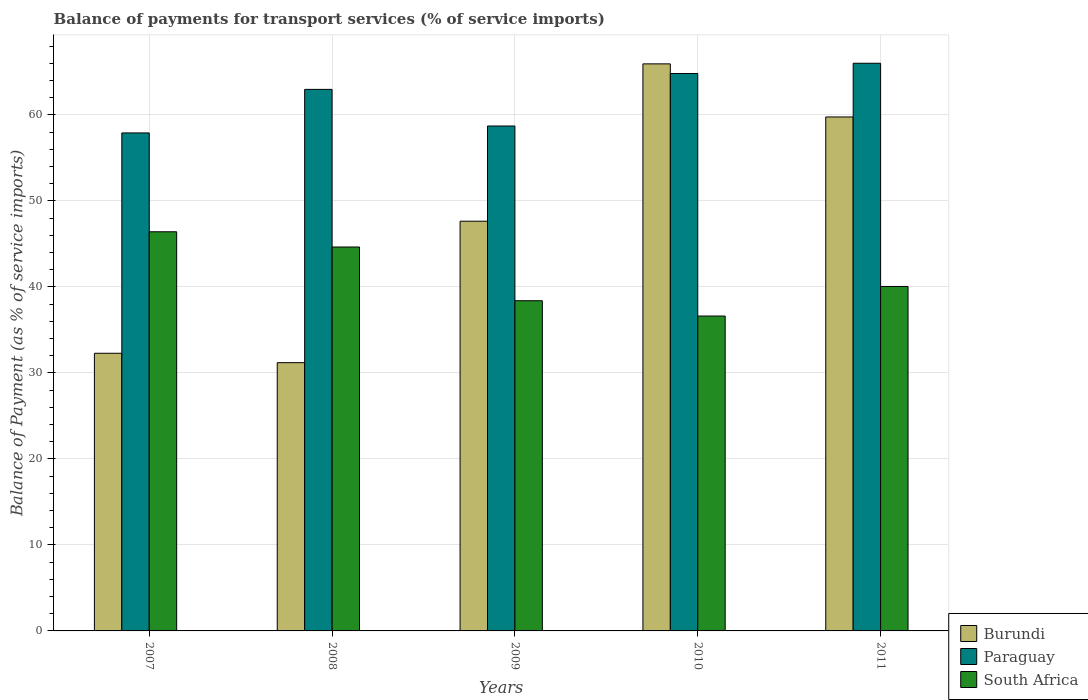How many different coloured bars are there?
Your answer should be very brief. 3. Are the number of bars on each tick of the X-axis equal?
Your answer should be compact. Yes. How many bars are there on the 4th tick from the right?
Make the answer very short. 3. What is the balance of payments for transport services in Paraguay in 2009?
Your response must be concise. 58.71. Across all years, what is the maximum balance of payments for transport services in Burundi?
Offer a very short reply. 65.93. Across all years, what is the minimum balance of payments for transport services in South Africa?
Your answer should be compact. 36.61. In which year was the balance of payments for transport services in South Africa maximum?
Your response must be concise. 2007. In which year was the balance of payments for transport services in South Africa minimum?
Give a very brief answer. 2010. What is the total balance of payments for transport services in Paraguay in the graph?
Your response must be concise. 310.39. What is the difference between the balance of payments for transport services in South Africa in 2007 and that in 2008?
Provide a short and direct response. 1.77. What is the difference between the balance of payments for transport services in South Africa in 2007 and the balance of payments for transport services in Burundi in 2010?
Provide a succinct answer. -19.52. What is the average balance of payments for transport services in Paraguay per year?
Make the answer very short. 62.08. In the year 2007, what is the difference between the balance of payments for transport services in Burundi and balance of payments for transport services in South Africa?
Your answer should be very brief. -14.13. What is the ratio of the balance of payments for transport services in Burundi in 2007 to that in 2009?
Provide a succinct answer. 0.68. Is the difference between the balance of payments for transport services in Burundi in 2007 and 2009 greater than the difference between the balance of payments for transport services in South Africa in 2007 and 2009?
Your answer should be compact. No. What is the difference between the highest and the second highest balance of payments for transport services in Paraguay?
Ensure brevity in your answer.  1.19. What is the difference between the highest and the lowest balance of payments for transport services in South Africa?
Ensure brevity in your answer.  9.8. In how many years, is the balance of payments for transport services in South Africa greater than the average balance of payments for transport services in South Africa taken over all years?
Offer a very short reply. 2. What does the 1st bar from the left in 2008 represents?
Give a very brief answer. Burundi. What does the 3rd bar from the right in 2010 represents?
Offer a very short reply. Burundi. Is it the case that in every year, the sum of the balance of payments for transport services in Burundi and balance of payments for transport services in South Africa is greater than the balance of payments for transport services in Paraguay?
Your answer should be compact. Yes. How many bars are there?
Ensure brevity in your answer.  15. Are the values on the major ticks of Y-axis written in scientific E-notation?
Ensure brevity in your answer.  No. Does the graph contain any zero values?
Your response must be concise. No. Where does the legend appear in the graph?
Offer a terse response. Bottom right. How many legend labels are there?
Provide a short and direct response. 3. What is the title of the graph?
Offer a terse response. Balance of payments for transport services (% of service imports). Does "South Asia" appear as one of the legend labels in the graph?
Make the answer very short. No. What is the label or title of the X-axis?
Provide a succinct answer. Years. What is the label or title of the Y-axis?
Offer a very short reply. Balance of Payment (as % of service imports). What is the Balance of Payment (as % of service imports) in Burundi in 2007?
Ensure brevity in your answer.  32.28. What is the Balance of Payment (as % of service imports) in Paraguay in 2007?
Your answer should be compact. 57.9. What is the Balance of Payment (as % of service imports) in South Africa in 2007?
Your answer should be very brief. 46.41. What is the Balance of Payment (as % of service imports) of Burundi in 2008?
Offer a very short reply. 31.19. What is the Balance of Payment (as % of service imports) in Paraguay in 2008?
Ensure brevity in your answer.  62.97. What is the Balance of Payment (as % of service imports) in South Africa in 2008?
Provide a succinct answer. 44.64. What is the Balance of Payment (as % of service imports) in Burundi in 2009?
Offer a terse response. 47.64. What is the Balance of Payment (as % of service imports) of Paraguay in 2009?
Provide a short and direct response. 58.71. What is the Balance of Payment (as % of service imports) of South Africa in 2009?
Provide a succinct answer. 38.39. What is the Balance of Payment (as % of service imports) of Burundi in 2010?
Keep it short and to the point. 65.93. What is the Balance of Payment (as % of service imports) of Paraguay in 2010?
Your answer should be compact. 64.81. What is the Balance of Payment (as % of service imports) in South Africa in 2010?
Provide a succinct answer. 36.61. What is the Balance of Payment (as % of service imports) of Burundi in 2011?
Provide a short and direct response. 59.76. What is the Balance of Payment (as % of service imports) in Paraguay in 2011?
Your response must be concise. 66. What is the Balance of Payment (as % of service imports) of South Africa in 2011?
Your answer should be very brief. 40.05. Across all years, what is the maximum Balance of Payment (as % of service imports) of Burundi?
Ensure brevity in your answer.  65.93. Across all years, what is the maximum Balance of Payment (as % of service imports) in Paraguay?
Your response must be concise. 66. Across all years, what is the maximum Balance of Payment (as % of service imports) of South Africa?
Make the answer very short. 46.41. Across all years, what is the minimum Balance of Payment (as % of service imports) of Burundi?
Your response must be concise. 31.19. Across all years, what is the minimum Balance of Payment (as % of service imports) in Paraguay?
Keep it short and to the point. 57.9. Across all years, what is the minimum Balance of Payment (as % of service imports) of South Africa?
Give a very brief answer. 36.61. What is the total Balance of Payment (as % of service imports) of Burundi in the graph?
Provide a succinct answer. 236.81. What is the total Balance of Payment (as % of service imports) of Paraguay in the graph?
Your answer should be compact. 310.39. What is the total Balance of Payment (as % of service imports) in South Africa in the graph?
Ensure brevity in your answer.  206.1. What is the difference between the Balance of Payment (as % of service imports) of Burundi in 2007 and that in 2008?
Your response must be concise. 1.09. What is the difference between the Balance of Payment (as % of service imports) in Paraguay in 2007 and that in 2008?
Offer a very short reply. -5.06. What is the difference between the Balance of Payment (as % of service imports) of South Africa in 2007 and that in 2008?
Your response must be concise. 1.77. What is the difference between the Balance of Payment (as % of service imports) of Burundi in 2007 and that in 2009?
Your answer should be very brief. -15.36. What is the difference between the Balance of Payment (as % of service imports) of Paraguay in 2007 and that in 2009?
Make the answer very short. -0.81. What is the difference between the Balance of Payment (as % of service imports) of South Africa in 2007 and that in 2009?
Offer a terse response. 8.02. What is the difference between the Balance of Payment (as % of service imports) of Burundi in 2007 and that in 2010?
Provide a short and direct response. -33.65. What is the difference between the Balance of Payment (as % of service imports) of Paraguay in 2007 and that in 2010?
Your response must be concise. -6.91. What is the difference between the Balance of Payment (as % of service imports) of South Africa in 2007 and that in 2010?
Keep it short and to the point. 9.8. What is the difference between the Balance of Payment (as % of service imports) of Burundi in 2007 and that in 2011?
Provide a succinct answer. -27.48. What is the difference between the Balance of Payment (as % of service imports) of Paraguay in 2007 and that in 2011?
Ensure brevity in your answer.  -8.1. What is the difference between the Balance of Payment (as % of service imports) in South Africa in 2007 and that in 2011?
Your answer should be compact. 6.36. What is the difference between the Balance of Payment (as % of service imports) in Burundi in 2008 and that in 2009?
Make the answer very short. -16.45. What is the difference between the Balance of Payment (as % of service imports) of Paraguay in 2008 and that in 2009?
Provide a succinct answer. 4.26. What is the difference between the Balance of Payment (as % of service imports) of South Africa in 2008 and that in 2009?
Your answer should be very brief. 6.25. What is the difference between the Balance of Payment (as % of service imports) in Burundi in 2008 and that in 2010?
Your answer should be very brief. -34.74. What is the difference between the Balance of Payment (as % of service imports) of Paraguay in 2008 and that in 2010?
Your answer should be compact. -1.85. What is the difference between the Balance of Payment (as % of service imports) in South Africa in 2008 and that in 2010?
Make the answer very short. 8.03. What is the difference between the Balance of Payment (as % of service imports) in Burundi in 2008 and that in 2011?
Provide a succinct answer. -28.57. What is the difference between the Balance of Payment (as % of service imports) of Paraguay in 2008 and that in 2011?
Give a very brief answer. -3.04. What is the difference between the Balance of Payment (as % of service imports) of South Africa in 2008 and that in 2011?
Your response must be concise. 4.59. What is the difference between the Balance of Payment (as % of service imports) of Burundi in 2009 and that in 2010?
Your answer should be compact. -18.3. What is the difference between the Balance of Payment (as % of service imports) of Paraguay in 2009 and that in 2010?
Provide a succinct answer. -6.1. What is the difference between the Balance of Payment (as % of service imports) of South Africa in 2009 and that in 2010?
Provide a succinct answer. 1.78. What is the difference between the Balance of Payment (as % of service imports) in Burundi in 2009 and that in 2011?
Give a very brief answer. -12.12. What is the difference between the Balance of Payment (as % of service imports) in Paraguay in 2009 and that in 2011?
Make the answer very short. -7.29. What is the difference between the Balance of Payment (as % of service imports) in South Africa in 2009 and that in 2011?
Provide a short and direct response. -1.66. What is the difference between the Balance of Payment (as % of service imports) in Burundi in 2010 and that in 2011?
Provide a short and direct response. 6.17. What is the difference between the Balance of Payment (as % of service imports) of Paraguay in 2010 and that in 2011?
Offer a terse response. -1.19. What is the difference between the Balance of Payment (as % of service imports) in South Africa in 2010 and that in 2011?
Keep it short and to the point. -3.44. What is the difference between the Balance of Payment (as % of service imports) of Burundi in 2007 and the Balance of Payment (as % of service imports) of Paraguay in 2008?
Provide a short and direct response. -30.68. What is the difference between the Balance of Payment (as % of service imports) in Burundi in 2007 and the Balance of Payment (as % of service imports) in South Africa in 2008?
Provide a succinct answer. -12.36. What is the difference between the Balance of Payment (as % of service imports) in Paraguay in 2007 and the Balance of Payment (as % of service imports) in South Africa in 2008?
Your answer should be very brief. 13.26. What is the difference between the Balance of Payment (as % of service imports) of Burundi in 2007 and the Balance of Payment (as % of service imports) of Paraguay in 2009?
Provide a short and direct response. -26.43. What is the difference between the Balance of Payment (as % of service imports) in Burundi in 2007 and the Balance of Payment (as % of service imports) in South Africa in 2009?
Provide a short and direct response. -6.11. What is the difference between the Balance of Payment (as % of service imports) of Paraguay in 2007 and the Balance of Payment (as % of service imports) of South Africa in 2009?
Your response must be concise. 19.51. What is the difference between the Balance of Payment (as % of service imports) in Burundi in 2007 and the Balance of Payment (as % of service imports) in Paraguay in 2010?
Provide a succinct answer. -32.53. What is the difference between the Balance of Payment (as % of service imports) in Burundi in 2007 and the Balance of Payment (as % of service imports) in South Africa in 2010?
Ensure brevity in your answer.  -4.33. What is the difference between the Balance of Payment (as % of service imports) of Paraguay in 2007 and the Balance of Payment (as % of service imports) of South Africa in 2010?
Give a very brief answer. 21.29. What is the difference between the Balance of Payment (as % of service imports) in Burundi in 2007 and the Balance of Payment (as % of service imports) in Paraguay in 2011?
Give a very brief answer. -33.72. What is the difference between the Balance of Payment (as % of service imports) of Burundi in 2007 and the Balance of Payment (as % of service imports) of South Africa in 2011?
Your response must be concise. -7.77. What is the difference between the Balance of Payment (as % of service imports) of Paraguay in 2007 and the Balance of Payment (as % of service imports) of South Africa in 2011?
Ensure brevity in your answer.  17.85. What is the difference between the Balance of Payment (as % of service imports) in Burundi in 2008 and the Balance of Payment (as % of service imports) in Paraguay in 2009?
Keep it short and to the point. -27.52. What is the difference between the Balance of Payment (as % of service imports) in Burundi in 2008 and the Balance of Payment (as % of service imports) in South Africa in 2009?
Offer a terse response. -7.2. What is the difference between the Balance of Payment (as % of service imports) in Paraguay in 2008 and the Balance of Payment (as % of service imports) in South Africa in 2009?
Provide a succinct answer. 24.57. What is the difference between the Balance of Payment (as % of service imports) of Burundi in 2008 and the Balance of Payment (as % of service imports) of Paraguay in 2010?
Offer a terse response. -33.62. What is the difference between the Balance of Payment (as % of service imports) in Burundi in 2008 and the Balance of Payment (as % of service imports) in South Africa in 2010?
Offer a very short reply. -5.42. What is the difference between the Balance of Payment (as % of service imports) in Paraguay in 2008 and the Balance of Payment (as % of service imports) in South Africa in 2010?
Keep it short and to the point. 26.35. What is the difference between the Balance of Payment (as % of service imports) in Burundi in 2008 and the Balance of Payment (as % of service imports) in Paraguay in 2011?
Your response must be concise. -34.81. What is the difference between the Balance of Payment (as % of service imports) in Burundi in 2008 and the Balance of Payment (as % of service imports) in South Africa in 2011?
Your answer should be compact. -8.86. What is the difference between the Balance of Payment (as % of service imports) of Paraguay in 2008 and the Balance of Payment (as % of service imports) of South Africa in 2011?
Make the answer very short. 22.91. What is the difference between the Balance of Payment (as % of service imports) of Burundi in 2009 and the Balance of Payment (as % of service imports) of Paraguay in 2010?
Your answer should be very brief. -17.17. What is the difference between the Balance of Payment (as % of service imports) in Burundi in 2009 and the Balance of Payment (as % of service imports) in South Africa in 2010?
Ensure brevity in your answer.  11.03. What is the difference between the Balance of Payment (as % of service imports) of Paraguay in 2009 and the Balance of Payment (as % of service imports) of South Africa in 2010?
Give a very brief answer. 22.1. What is the difference between the Balance of Payment (as % of service imports) of Burundi in 2009 and the Balance of Payment (as % of service imports) of Paraguay in 2011?
Ensure brevity in your answer.  -18.37. What is the difference between the Balance of Payment (as % of service imports) in Burundi in 2009 and the Balance of Payment (as % of service imports) in South Africa in 2011?
Provide a succinct answer. 7.59. What is the difference between the Balance of Payment (as % of service imports) in Paraguay in 2009 and the Balance of Payment (as % of service imports) in South Africa in 2011?
Your response must be concise. 18.66. What is the difference between the Balance of Payment (as % of service imports) in Burundi in 2010 and the Balance of Payment (as % of service imports) in Paraguay in 2011?
Provide a short and direct response. -0.07. What is the difference between the Balance of Payment (as % of service imports) in Burundi in 2010 and the Balance of Payment (as % of service imports) in South Africa in 2011?
Provide a succinct answer. 25.88. What is the difference between the Balance of Payment (as % of service imports) in Paraguay in 2010 and the Balance of Payment (as % of service imports) in South Africa in 2011?
Provide a succinct answer. 24.76. What is the average Balance of Payment (as % of service imports) in Burundi per year?
Your answer should be very brief. 47.36. What is the average Balance of Payment (as % of service imports) of Paraguay per year?
Offer a terse response. 62.08. What is the average Balance of Payment (as % of service imports) of South Africa per year?
Offer a terse response. 41.22. In the year 2007, what is the difference between the Balance of Payment (as % of service imports) in Burundi and Balance of Payment (as % of service imports) in Paraguay?
Ensure brevity in your answer.  -25.62. In the year 2007, what is the difference between the Balance of Payment (as % of service imports) in Burundi and Balance of Payment (as % of service imports) in South Africa?
Ensure brevity in your answer.  -14.13. In the year 2007, what is the difference between the Balance of Payment (as % of service imports) of Paraguay and Balance of Payment (as % of service imports) of South Africa?
Your answer should be compact. 11.49. In the year 2008, what is the difference between the Balance of Payment (as % of service imports) in Burundi and Balance of Payment (as % of service imports) in Paraguay?
Give a very brief answer. -31.77. In the year 2008, what is the difference between the Balance of Payment (as % of service imports) of Burundi and Balance of Payment (as % of service imports) of South Africa?
Your response must be concise. -13.45. In the year 2008, what is the difference between the Balance of Payment (as % of service imports) of Paraguay and Balance of Payment (as % of service imports) of South Africa?
Provide a succinct answer. 18.33. In the year 2009, what is the difference between the Balance of Payment (as % of service imports) in Burundi and Balance of Payment (as % of service imports) in Paraguay?
Your response must be concise. -11.07. In the year 2009, what is the difference between the Balance of Payment (as % of service imports) in Burundi and Balance of Payment (as % of service imports) in South Africa?
Provide a succinct answer. 9.25. In the year 2009, what is the difference between the Balance of Payment (as % of service imports) of Paraguay and Balance of Payment (as % of service imports) of South Africa?
Provide a short and direct response. 20.32. In the year 2010, what is the difference between the Balance of Payment (as % of service imports) in Burundi and Balance of Payment (as % of service imports) in Paraguay?
Provide a short and direct response. 1.12. In the year 2010, what is the difference between the Balance of Payment (as % of service imports) in Burundi and Balance of Payment (as % of service imports) in South Africa?
Provide a short and direct response. 29.32. In the year 2010, what is the difference between the Balance of Payment (as % of service imports) in Paraguay and Balance of Payment (as % of service imports) in South Africa?
Provide a succinct answer. 28.2. In the year 2011, what is the difference between the Balance of Payment (as % of service imports) of Burundi and Balance of Payment (as % of service imports) of Paraguay?
Offer a very short reply. -6.24. In the year 2011, what is the difference between the Balance of Payment (as % of service imports) in Burundi and Balance of Payment (as % of service imports) in South Africa?
Provide a short and direct response. 19.71. In the year 2011, what is the difference between the Balance of Payment (as % of service imports) in Paraguay and Balance of Payment (as % of service imports) in South Africa?
Give a very brief answer. 25.95. What is the ratio of the Balance of Payment (as % of service imports) in Burundi in 2007 to that in 2008?
Make the answer very short. 1.03. What is the ratio of the Balance of Payment (as % of service imports) in Paraguay in 2007 to that in 2008?
Ensure brevity in your answer.  0.92. What is the ratio of the Balance of Payment (as % of service imports) in South Africa in 2007 to that in 2008?
Provide a short and direct response. 1.04. What is the ratio of the Balance of Payment (as % of service imports) in Burundi in 2007 to that in 2009?
Offer a very short reply. 0.68. What is the ratio of the Balance of Payment (as % of service imports) of Paraguay in 2007 to that in 2009?
Make the answer very short. 0.99. What is the ratio of the Balance of Payment (as % of service imports) of South Africa in 2007 to that in 2009?
Provide a short and direct response. 1.21. What is the ratio of the Balance of Payment (as % of service imports) of Burundi in 2007 to that in 2010?
Make the answer very short. 0.49. What is the ratio of the Balance of Payment (as % of service imports) of Paraguay in 2007 to that in 2010?
Give a very brief answer. 0.89. What is the ratio of the Balance of Payment (as % of service imports) in South Africa in 2007 to that in 2010?
Your answer should be very brief. 1.27. What is the ratio of the Balance of Payment (as % of service imports) of Burundi in 2007 to that in 2011?
Provide a short and direct response. 0.54. What is the ratio of the Balance of Payment (as % of service imports) in Paraguay in 2007 to that in 2011?
Keep it short and to the point. 0.88. What is the ratio of the Balance of Payment (as % of service imports) in South Africa in 2007 to that in 2011?
Make the answer very short. 1.16. What is the ratio of the Balance of Payment (as % of service imports) in Burundi in 2008 to that in 2009?
Make the answer very short. 0.65. What is the ratio of the Balance of Payment (as % of service imports) in Paraguay in 2008 to that in 2009?
Keep it short and to the point. 1.07. What is the ratio of the Balance of Payment (as % of service imports) in South Africa in 2008 to that in 2009?
Your answer should be compact. 1.16. What is the ratio of the Balance of Payment (as % of service imports) in Burundi in 2008 to that in 2010?
Keep it short and to the point. 0.47. What is the ratio of the Balance of Payment (as % of service imports) of Paraguay in 2008 to that in 2010?
Your answer should be compact. 0.97. What is the ratio of the Balance of Payment (as % of service imports) in South Africa in 2008 to that in 2010?
Provide a short and direct response. 1.22. What is the ratio of the Balance of Payment (as % of service imports) of Burundi in 2008 to that in 2011?
Keep it short and to the point. 0.52. What is the ratio of the Balance of Payment (as % of service imports) in Paraguay in 2008 to that in 2011?
Offer a terse response. 0.95. What is the ratio of the Balance of Payment (as % of service imports) in South Africa in 2008 to that in 2011?
Provide a short and direct response. 1.11. What is the ratio of the Balance of Payment (as % of service imports) of Burundi in 2009 to that in 2010?
Ensure brevity in your answer.  0.72. What is the ratio of the Balance of Payment (as % of service imports) in Paraguay in 2009 to that in 2010?
Ensure brevity in your answer.  0.91. What is the ratio of the Balance of Payment (as % of service imports) in South Africa in 2009 to that in 2010?
Your response must be concise. 1.05. What is the ratio of the Balance of Payment (as % of service imports) in Burundi in 2009 to that in 2011?
Your answer should be very brief. 0.8. What is the ratio of the Balance of Payment (as % of service imports) in Paraguay in 2009 to that in 2011?
Make the answer very short. 0.89. What is the ratio of the Balance of Payment (as % of service imports) in South Africa in 2009 to that in 2011?
Offer a very short reply. 0.96. What is the ratio of the Balance of Payment (as % of service imports) of Burundi in 2010 to that in 2011?
Your answer should be compact. 1.1. What is the ratio of the Balance of Payment (as % of service imports) in Paraguay in 2010 to that in 2011?
Make the answer very short. 0.98. What is the ratio of the Balance of Payment (as % of service imports) of South Africa in 2010 to that in 2011?
Your answer should be compact. 0.91. What is the difference between the highest and the second highest Balance of Payment (as % of service imports) in Burundi?
Give a very brief answer. 6.17. What is the difference between the highest and the second highest Balance of Payment (as % of service imports) of Paraguay?
Ensure brevity in your answer.  1.19. What is the difference between the highest and the second highest Balance of Payment (as % of service imports) of South Africa?
Make the answer very short. 1.77. What is the difference between the highest and the lowest Balance of Payment (as % of service imports) in Burundi?
Your answer should be very brief. 34.74. What is the difference between the highest and the lowest Balance of Payment (as % of service imports) in Paraguay?
Your answer should be compact. 8.1. What is the difference between the highest and the lowest Balance of Payment (as % of service imports) of South Africa?
Keep it short and to the point. 9.8. 